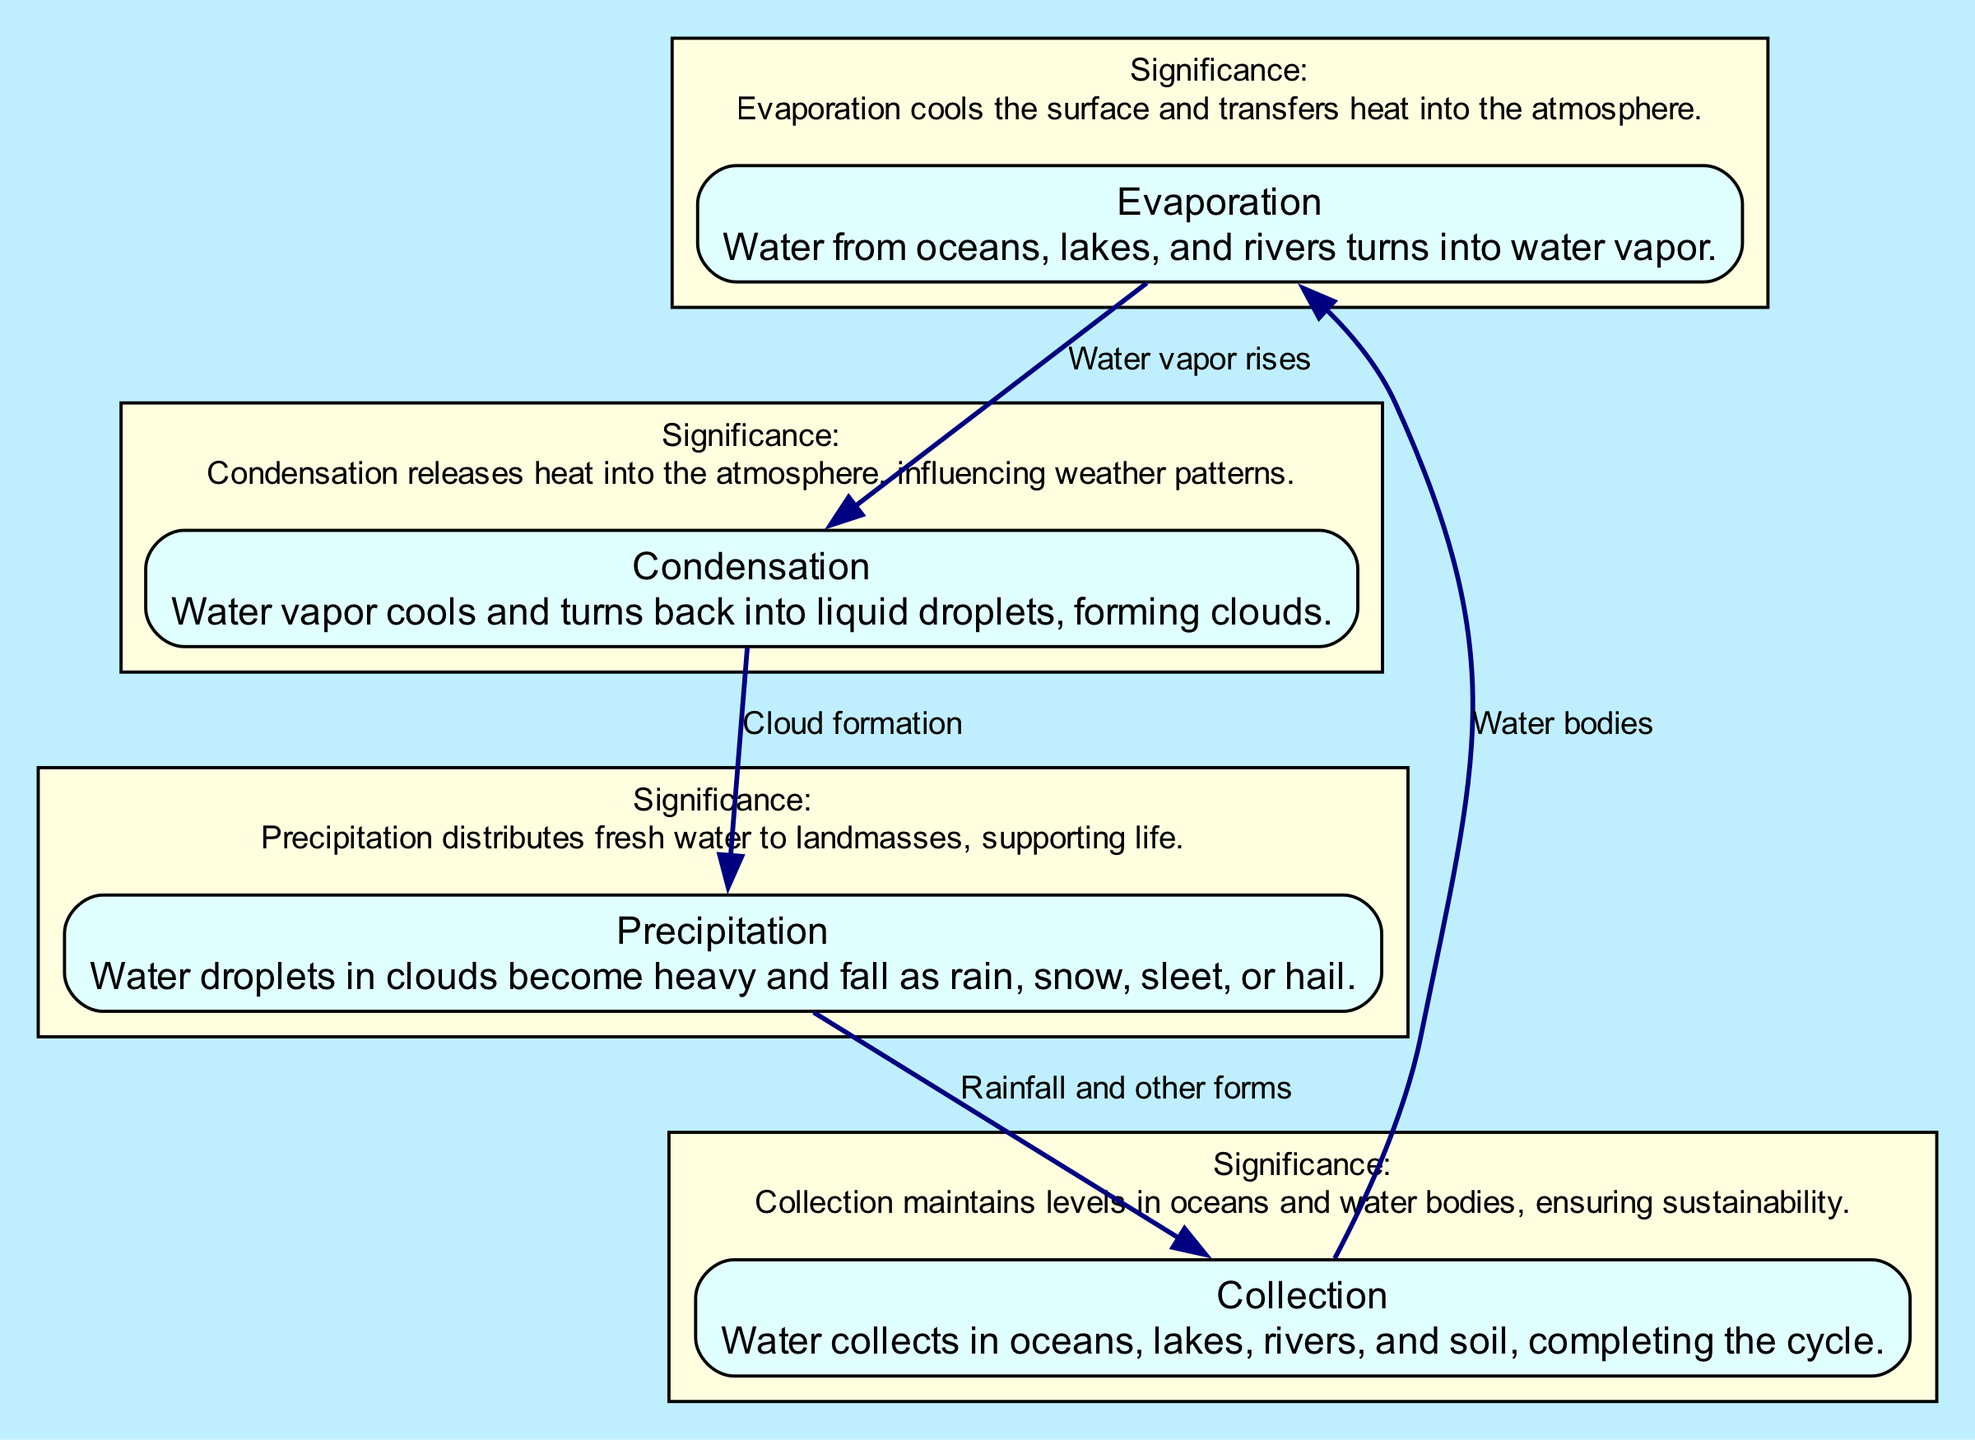What is the first process in the water cycle? The diagram identifies "Evaporation" as the first process, which is depicted at the top.
Answer: Evaporation How many key processes are represented in the diagram? The diagram lists four key processes: Evaporation, Condensation, Precipitation, and Collection, which are shown as nodes.
Answer: Four What happens to water vapor in the condensation process? According to the diagram, water vapor cools and turns back into liquid droplets, forming clouds.
Answer: Turns back into liquid droplets What do clouds do in the precipitation process? The diagram states that water droplets in clouds become heavy and fall, indicating that clouds release water in various forms.
Answer: Release water Which process follows precipitation in the water cycle? The diagram shows that after precipitation, the next process is "Collection," indicating where water accumulates.
Answer: Collection What label is associated with the collection process? The collection process is labeled as the point where water collects in oceans, lakes, rivers, and soil, completing the cycle.
Answer: Collects in oceans, lakes, rivers, and soil What role does evaporation play in the Earth's climate system? The diagram notes that evaporation cools the surface and transfers heat into the atmosphere, impacting climate.
Answer: Cools the surface and transfers heat How does condensation affect weather patterns? The diagram indicates that condensation releases heat into the atmosphere, which influences weather patterns.
Answer: Releases heat into the atmosphere What is the significance of precipitation in the water cycle? The diagram explains that precipitation distributes fresh water to landmasses, supporting life and maintaining ecosystems.
Answer: Distributes fresh water to landmasses 